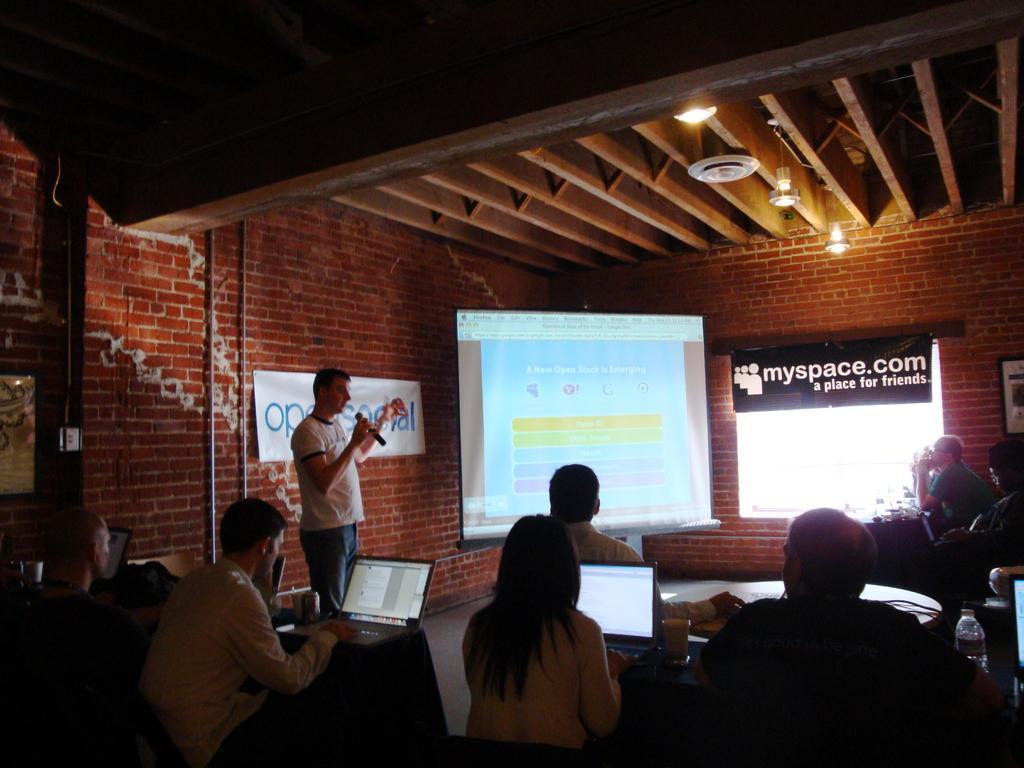Describe this image in one or two sentences. In this picture we can see a projector screen, banner, beams, lights, poles and few objects. We can see people sitting. We can see laptops, glass, bottle, table. On the right side of the picture it looks like a frame on the wall. On the left side of the picture we can see a man is standing and he is holding a microphone, looks like he is talking. 